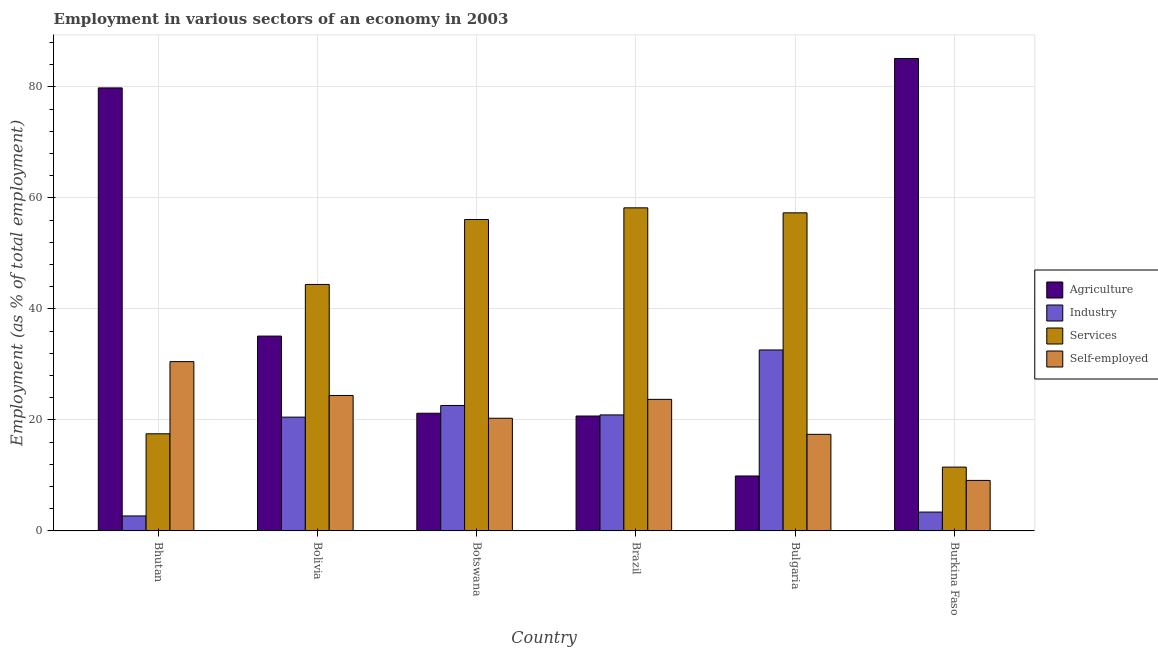How many groups of bars are there?
Give a very brief answer. 6. Are the number of bars on each tick of the X-axis equal?
Offer a terse response. Yes. How many bars are there on the 5th tick from the right?
Ensure brevity in your answer.  4. In how many cases, is the number of bars for a given country not equal to the number of legend labels?
Your answer should be compact. 0. What is the percentage of workers in industry in Bulgaria?
Offer a terse response. 32.6. Across all countries, what is the maximum percentage of workers in agriculture?
Provide a succinct answer. 85.1. Across all countries, what is the minimum percentage of self employed workers?
Provide a succinct answer. 9.1. In which country was the percentage of workers in agriculture maximum?
Keep it short and to the point. Burkina Faso. In which country was the percentage of workers in agriculture minimum?
Ensure brevity in your answer.  Bulgaria. What is the total percentage of workers in industry in the graph?
Your response must be concise. 102.7. What is the difference between the percentage of workers in services in Bolivia and that in Bulgaria?
Your answer should be very brief. -12.9. What is the difference between the percentage of self employed workers in Burkina Faso and the percentage of workers in services in Bulgaria?
Your answer should be very brief. -48.2. What is the average percentage of self employed workers per country?
Provide a succinct answer. 20.9. What is the difference between the percentage of workers in services and percentage of workers in agriculture in Brazil?
Offer a very short reply. 37.5. What is the ratio of the percentage of self employed workers in Bhutan to that in Bolivia?
Offer a terse response. 1.25. What is the difference between the highest and the second highest percentage of workers in services?
Your answer should be compact. 0.9. What is the difference between the highest and the lowest percentage of workers in agriculture?
Offer a very short reply. 75.2. In how many countries, is the percentage of workers in industry greater than the average percentage of workers in industry taken over all countries?
Your response must be concise. 4. Is the sum of the percentage of workers in agriculture in Bolivia and Botswana greater than the maximum percentage of workers in services across all countries?
Offer a terse response. No. Is it the case that in every country, the sum of the percentage of workers in industry and percentage of self employed workers is greater than the sum of percentage of workers in agriculture and percentage of workers in services?
Ensure brevity in your answer.  No. What does the 1st bar from the left in Bulgaria represents?
Make the answer very short. Agriculture. What does the 2nd bar from the right in Botswana represents?
Offer a very short reply. Services. Is it the case that in every country, the sum of the percentage of workers in agriculture and percentage of workers in industry is greater than the percentage of workers in services?
Keep it short and to the point. No. Are the values on the major ticks of Y-axis written in scientific E-notation?
Offer a very short reply. No. Does the graph contain grids?
Your response must be concise. Yes. How are the legend labels stacked?
Your answer should be compact. Vertical. What is the title of the graph?
Your response must be concise. Employment in various sectors of an economy in 2003. Does "Ease of arranging shipments" appear as one of the legend labels in the graph?
Offer a terse response. No. What is the label or title of the Y-axis?
Provide a short and direct response. Employment (as % of total employment). What is the Employment (as % of total employment) in Agriculture in Bhutan?
Provide a short and direct response. 79.8. What is the Employment (as % of total employment) in Industry in Bhutan?
Provide a succinct answer. 2.7. What is the Employment (as % of total employment) of Services in Bhutan?
Ensure brevity in your answer.  17.5. What is the Employment (as % of total employment) of Self-employed in Bhutan?
Ensure brevity in your answer.  30.5. What is the Employment (as % of total employment) in Agriculture in Bolivia?
Your answer should be very brief. 35.1. What is the Employment (as % of total employment) of Industry in Bolivia?
Your answer should be very brief. 20.5. What is the Employment (as % of total employment) of Services in Bolivia?
Your response must be concise. 44.4. What is the Employment (as % of total employment) of Self-employed in Bolivia?
Offer a very short reply. 24.4. What is the Employment (as % of total employment) of Agriculture in Botswana?
Provide a short and direct response. 21.2. What is the Employment (as % of total employment) of Industry in Botswana?
Make the answer very short. 22.6. What is the Employment (as % of total employment) of Services in Botswana?
Keep it short and to the point. 56.1. What is the Employment (as % of total employment) of Self-employed in Botswana?
Make the answer very short. 20.3. What is the Employment (as % of total employment) of Agriculture in Brazil?
Provide a short and direct response. 20.7. What is the Employment (as % of total employment) in Industry in Brazil?
Offer a very short reply. 20.9. What is the Employment (as % of total employment) of Services in Brazil?
Keep it short and to the point. 58.2. What is the Employment (as % of total employment) of Self-employed in Brazil?
Make the answer very short. 23.7. What is the Employment (as % of total employment) of Agriculture in Bulgaria?
Ensure brevity in your answer.  9.9. What is the Employment (as % of total employment) in Industry in Bulgaria?
Your answer should be very brief. 32.6. What is the Employment (as % of total employment) in Services in Bulgaria?
Ensure brevity in your answer.  57.3. What is the Employment (as % of total employment) of Self-employed in Bulgaria?
Offer a terse response. 17.4. What is the Employment (as % of total employment) of Agriculture in Burkina Faso?
Offer a very short reply. 85.1. What is the Employment (as % of total employment) of Industry in Burkina Faso?
Give a very brief answer. 3.4. What is the Employment (as % of total employment) of Self-employed in Burkina Faso?
Ensure brevity in your answer.  9.1. Across all countries, what is the maximum Employment (as % of total employment) of Agriculture?
Your answer should be compact. 85.1. Across all countries, what is the maximum Employment (as % of total employment) of Industry?
Give a very brief answer. 32.6. Across all countries, what is the maximum Employment (as % of total employment) in Services?
Provide a short and direct response. 58.2. Across all countries, what is the maximum Employment (as % of total employment) in Self-employed?
Your answer should be very brief. 30.5. Across all countries, what is the minimum Employment (as % of total employment) in Agriculture?
Your answer should be very brief. 9.9. Across all countries, what is the minimum Employment (as % of total employment) of Industry?
Ensure brevity in your answer.  2.7. Across all countries, what is the minimum Employment (as % of total employment) of Self-employed?
Your answer should be compact. 9.1. What is the total Employment (as % of total employment) of Agriculture in the graph?
Offer a terse response. 251.8. What is the total Employment (as % of total employment) in Industry in the graph?
Your answer should be very brief. 102.7. What is the total Employment (as % of total employment) in Services in the graph?
Provide a succinct answer. 245. What is the total Employment (as % of total employment) in Self-employed in the graph?
Make the answer very short. 125.4. What is the difference between the Employment (as % of total employment) of Agriculture in Bhutan and that in Bolivia?
Your answer should be compact. 44.7. What is the difference between the Employment (as % of total employment) in Industry in Bhutan and that in Bolivia?
Give a very brief answer. -17.8. What is the difference between the Employment (as % of total employment) in Services in Bhutan and that in Bolivia?
Your answer should be very brief. -26.9. What is the difference between the Employment (as % of total employment) in Self-employed in Bhutan and that in Bolivia?
Offer a terse response. 6.1. What is the difference between the Employment (as % of total employment) in Agriculture in Bhutan and that in Botswana?
Offer a terse response. 58.6. What is the difference between the Employment (as % of total employment) in Industry in Bhutan and that in Botswana?
Your answer should be very brief. -19.9. What is the difference between the Employment (as % of total employment) in Services in Bhutan and that in Botswana?
Give a very brief answer. -38.6. What is the difference between the Employment (as % of total employment) in Self-employed in Bhutan and that in Botswana?
Your answer should be compact. 10.2. What is the difference between the Employment (as % of total employment) in Agriculture in Bhutan and that in Brazil?
Ensure brevity in your answer.  59.1. What is the difference between the Employment (as % of total employment) in Industry in Bhutan and that in Brazil?
Ensure brevity in your answer.  -18.2. What is the difference between the Employment (as % of total employment) of Services in Bhutan and that in Brazil?
Keep it short and to the point. -40.7. What is the difference between the Employment (as % of total employment) of Self-employed in Bhutan and that in Brazil?
Your answer should be compact. 6.8. What is the difference between the Employment (as % of total employment) in Agriculture in Bhutan and that in Bulgaria?
Make the answer very short. 69.9. What is the difference between the Employment (as % of total employment) in Industry in Bhutan and that in Bulgaria?
Ensure brevity in your answer.  -29.9. What is the difference between the Employment (as % of total employment) of Services in Bhutan and that in Bulgaria?
Offer a very short reply. -39.8. What is the difference between the Employment (as % of total employment) of Self-employed in Bhutan and that in Burkina Faso?
Ensure brevity in your answer.  21.4. What is the difference between the Employment (as % of total employment) in Agriculture in Bolivia and that in Botswana?
Make the answer very short. 13.9. What is the difference between the Employment (as % of total employment) of Industry in Bolivia and that in Botswana?
Your answer should be compact. -2.1. What is the difference between the Employment (as % of total employment) of Self-employed in Bolivia and that in Botswana?
Ensure brevity in your answer.  4.1. What is the difference between the Employment (as % of total employment) of Agriculture in Bolivia and that in Brazil?
Your answer should be very brief. 14.4. What is the difference between the Employment (as % of total employment) in Self-employed in Bolivia and that in Brazil?
Your answer should be very brief. 0.7. What is the difference between the Employment (as % of total employment) in Agriculture in Bolivia and that in Bulgaria?
Provide a short and direct response. 25.2. What is the difference between the Employment (as % of total employment) of Services in Bolivia and that in Burkina Faso?
Offer a terse response. 32.9. What is the difference between the Employment (as % of total employment) in Agriculture in Botswana and that in Brazil?
Your answer should be very brief. 0.5. What is the difference between the Employment (as % of total employment) of Industry in Botswana and that in Brazil?
Offer a very short reply. 1.7. What is the difference between the Employment (as % of total employment) of Services in Botswana and that in Bulgaria?
Offer a terse response. -1.2. What is the difference between the Employment (as % of total employment) in Agriculture in Botswana and that in Burkina Faso?
Your answer should be compact. -63.9. What is the difference between the Employment (as % of total employment) of Industry in Botswana and that in Burkina Faso?
Keep it short and to the point. 19.2. What is the difference between the Employment (as % of total employment) in Services in Botswana and that in Burkina Faso?
Provide a short and direct response. 44.6. What is the difference between the Employment (as % of total employment) of Services in Brazil and that in Bulgaria?
Provide a short and direct response. 0.9. What is the difference between the Employment (as % of total employment) of Agriculture in Brazil and that in Burkina Faso?
Give a very brief answer. -64.4. What is the difference between the Employment (as % of total employment) in Services in Brazil and that in Burkina Faso?
Offer a very short reply. 46.7. What is the difference between the Employment (as % of total employment) of Agriculture in Bulgaria and that in Burkina Faso?
Offer a very short reply. -75.2. What is the difference between the Employment (as % of total employment) of Industry in Bulgaria and that in Burkina Faso?
Offer a very short reply. 29.2. What is the difference between the Employment (as % of total employment) in Services in Bulgaria and that in Burkina Faso?
Your response must be concise. 45.8. What is the difference between the Employment (as % of total employment) in Agriculture in Bhutan and the Employment (as % of total employment) in Industry in Bolivia?
Provide a short and direct response. 59.3. What is the difference between the Employment (as % of total employment) in Agriculture in Bhutan and the Employment (as % of total employment) in Services in Bolivia?
Make the answer very short. 35.4. What is the difference between the Employment (as % of total employment) in Agriculture in Bhutan and the Employment (as % of total employment) in Self-employed in Bolivia?
Your answer should be compact. 55.4. What is the difference between the Employment (as % of total employment) in Industry in Bhutan and the Employment (as % of total employment) in Services in Bolivia?
Offer a terse response. -41.7. What is the difference between the Employment (as % of total employment) in Industry in Bhutan and the Employment (as % of total employment) in Self-employed in Bolivia?
Give a very brief answer. -21.7. What is the difference between the Employment (as % of total employment) in Agriculture in Bhutan and the Employment (as % of total employment) in Industry in Botswana?
Your answer should be very brief. 57.2. What is the difference between the Employment (as % of total employment) of Agriculture in Bhutan and the Employment (as % of total employment) of Services in Botswana?
Offer a very short reply. 23.7. What is the difference between the Employment (as % of total employment) of Agriculture in Bhutan and the Employment (as % of total employment) of Self-employed in Botswana?
Your answer should be compact. 59.5. What is the difference between the Employment (as % of total employment) in Industry in Bhutan and the Employment (as % of total employment) in Services in Botswana?
Your answer should be compact. -53.4. What is the difference between the Employment (as % of total employment) in Industry in Bhutan and the Employment (as % of total employment) in Self-employed in Botswana?
Provide a short and direct response. -17.6. What is the difference between the Employment (as % of total employment) of Services in Bhutan and the Employment (as % of total employment) of Self-employed in Botswana?
Give a very brief answer. -2.8. What is the difference between the Employment (as % of total employment) in Agriculture in Bhutan and the Employment (as % of total employment) in Industry in Brazil?
Your answer should be very brief. 58.9. What is the difference between the Employment (as % of total employment) in Agriculture in Bhutan and the Employment (as % of total employment) in Services in Brazil?
Keep it short and to the point. 21.6. What is the difference between the Employment (as % of total employment) in Agriculture in Bhutan and the Employment (as % of total employment) in Self-employed in Brazil?
Provide a short and direct response. 56.1. What is the difference between the Employment (as % of total employment) of Industry in Bhutan and the Employment (as % of total employment) of Services in Brazil?
Provide a succinct answer. -55.5. What is the difference between the Employment (as % of total employment) of Services in Bhutan and the Employment (as % of total employment) of Self-employed in Brazil?
Give a very brief answer. -6.2. What is the difference between the Employment (as % of total employment) in Agriculture in Bhutan and the Employment (as % of total employment) in Industry in Bulgaria?
Make the answer very short. 47.2. What is the difference between the Employment (as % of total employment) of Agriculture in Bhutan and the Employment (as % of total employment) of Self-employed in Bulgaria?
Make the answer very short. 62.4. What is the difference between the Employment (as % of total employment) in Industry in Bhutan and the Employment (as % of total employment) in Services in Bulgaria?
Offer a terse response. -54.6. What is the difference between the Employment (as % of total employment) in Industry in Bhutan and the Employment (as % of total employment) in Self-employed in Bulgaria?
Ensure brevity in your answer.  -14.7. What is the difference between the Employment (as % of total employment) of Agriculture in Bhutan and the Employment (as % of total employment) of Industry in Burkina Faso?
Offer a terse response. 76.4. What is the difference between the Employment (as % of total employment) of Agriculture in Bhutan and the Employment (as % of total employment) of Services in Burkina Faso?
Ensure brevity in your answer.  68.3. What is the difference between the Employment (as % of total employment) of Agriculture in Bhutan and the Employment (as % of total employment) of Self-employed in Burkina Faso?
Keep it short and to the point. 70.7. What is the difference between the Employment (as % of total employment) of Industry in Bhutan and the Employment (as % of total employment) of Services in Burkina Faso?
Your answer should be compact. -8.8. What is the difference between the Employment (as % of total employment) of Industry in Bhutan and the Employment (as % of total employment) of Self-employed in Burkina Faso?
Ensure brevity in your answer.  -6.4. What is the difference between the Employment (as % of total employment) in Services in Bhutan and the Employment (as % of total employment) in Self-employed in Burkina Faso?
Your response must be concise. 8.4. What is the difference between the Employment (as % of total employment) of Agriculture in Bolivia and the Employment (as % of total employment) of Services in Botswana?
Give a very brief answer. -21. What is the difference between the Employment (as % of total employment) in Industry in Bolivia and the Employment (as % of total employment) in Services in Botswana?
Your answer should be very brief. -35.6. What is the difference between the Employment (as % of total employment) of Industry in Bolivia and the Employment (as % of total employment) of Self-employed in Botswana?
Your response must be concise. 0.2. What is the difference between the Employment (as % of total employment) in Services in Bolivia and the Employment (as % of total employment) in Self-employed in Botswana?
Make the answer very short. 24.1. What is the difference between the Employment (as % of total employment) in Agriculture in Bolivia and the Employment (as % of total employment) in Industry in Brazil?
Provide a succinct answer. 14.2. What is the difference between the Employment (as % of total employment) in Agriculture in Bolivia and the Employment (as % of total employment) in Services in Brazil?
Give a very brief answer. -23.1. What is the difference between the Employment (as % of total employment) of Industry in Bolivia and the Employment (as % of total employment) of Services in Brazil?
Your response must be concise. -37.7. What is the difference between the Employment (as % of total employment) of Services in Bolivia and the Employment (as % of total employment) of Self-employed in Brazil?
Offer a terse response. 20.7. What is the difference between the Employment (as % of total employment) in Agriculture in Bolivia and the Employment (as % of total employment) in Industry in Bulgaria?
Your response must be concise. 2.5. What is the difference between the Employment (as % of total employment) in Agriculture in Bolivia and the Employment (as % of total employment) in Services in Bulgaria?
Give a very brief answer. -22.2. What is the difference between the Employment (as % of total employment) of Industry in Bolivia and the Employment (as % of total employment) of Services in Bulgaria?
Keep it short and to the point. -36.8. What is the difference between the Employment (as % of total employment) in Services in Bolivia and the Employment (as % of total employment) in Self-employed in Bulgaria?
Provide a short and direct response. 27. What is the difference between the Employment (as % of total employment) in Agriculture in Bolivia and the Employment (as % of total employment) in Industry in Burkina Faso?
Provide a succinct answer. 31.7. What is the difference between the Employment (as % of total employment) of Agriculture in Bolivia and the Employment (as % of total employment) of Services in Burkina Faso?
Offer a very short reply. 23.6. What is the difference between the Employment (as % of total employment) in Services in Bolivia and the Employment (as % of total employment) in Self-employed in Burkina Faso?
Make the answer very short. 35.3. What is the difference between the Employment (as % of total employment) in Agriculture in Botswana and the Employment (as % of total employment) in Services in Brazil?
Make the answer very short. -37. What is the difference between the Employment (as % of total employment) in Agriculture in Botswana and the Employment (as % of total employment) in Self-employed in Brazil?
Give a very brief answer. -2.5. What is the difference between the Employment (as % of total employment) of Industry in Botswana and the Employment (as % of total employment) of Services in Brazil?
Your answer should be very brief. -35.6. What is the difference between the Employment (as % of total employment) of Industry in Botswana and the Employment (as % of total employment) of Self-employed in Brazil?
Your answer should be very brief. -1.1. What is the difference between the Employment (as % of total employment) in Services in Botswana and the Employment (as % of total employment) in Self-employed in Brazil?
Provide a short and direct response. 32.4. What is the difference between the Employment (as % of total employment) in Agriculture in Botswana and the Employment (as % of total employment) in Services in Bulgaria?
Ensure brevity in your answer.  -36.1. What is the difference between the Employment (as % of total employment) of Industry in Botswana and the Employment (as % of total employment) of Services in Bulgaria?
Ensure brevity in your answer.  -34.7. What is the difference between the Employment (as % of total employment) in Industry in Botswana and the Employment (as % of total employment) in Self-employed in Bulgaria?
Your response must be concise. 5.2. What is the difference between the Employment (as % of total employment) of Services in Botswana and the Employment (as % of total employment) of Self-employed in Bulgaria?
Make the answer very short. 38.7. What is the difference between the Employment (as % of total employment) of Agriculture in Botswana and the Employment (as % of total employment) of Industry in Burkina Faso?
Make the answer very short. 17.8. What is the difference between the Employment (as % of total employment) in Industry in Botswana and the Employment (as % of total employment) in Services in Burkina Faso?
Your answer should be compact. 11.1. What is the difference between the Employment (as % of total employment) in Services in Botswana and the Employment (as % of total employment) in Self-employed in Burkina Faso?
Keep it short and to the point. 47. What is the difference between the Employment (as % of total employment) of Agriculture in Brazil and the Employment (as % of total employment) of Industry in Bulgaria?
Give a very brief answer. -11.9. What is the difference between the Employment (as % of total employment) of Agriculture in Brazil and the Employment (as % of total employment) of Services in Bulgaria?
Provide a short and direct response. -36.6. What is the difference between the Employment (as % of total employment) of Industry in Brazil and the Employment (as % of total employment) of Services in Bulgaria?
Your answer should be very brief. -36.4. What is the difference between the Employment (as % of total employment) in Services in Brazil and the Employment (as % of total employment) in Self-employed in Bulgaria?
Your response must be concise. 40.8. What is the difference between the Employment (as % of total employment) of Industry in Brazil and the Employment (as % of total employment) of Self-employed in Burkina Faso?
Provide a short and direct response. 11.8. What is the difference between the Employment (as % of total employment) of Services in Brazil and the Employment (as % of total employment) of Self-employed in Burkina Faso?
Provide a short and direct response. 49.1. What is the difference between the Employment (as % of total employment) of Agriculture in Bulgaria and the Employment (as % of total employment) of Self-employed in Burkina Faso?
Your answer should be very brief. 0.8. What is the difference between the Employment (as % of total employment) in Industry in Bulgaria and the Employment (as % of total employment) in Services in Burkina Faso?
Make the answer very short. 21.1. What is the difference between the Employment (as % of total employment) of Services in Bulgaria and the Employment (as % of total employment) of Self-employed in Burkina Faso?
Provide a succinct answer. 48.2. What is the average Employment (as % of total employment) of Agriculture per country?
Give a very brief answer. 41.97. What is the average Employment (as % of total employment) in Industry per country?
Ensure brevity in your answer.  17.12. What is the average Employment (as % of total employment) in Services per country?
Ensure brevity in your answer.  40.83. What is the average Employment (as % of total employment) of Self-employed per country?
Your response must be concise. 20.9. What is the difference between the Employment (as % of total employment) of Agriculture and Employment (as % of total employment) of Industry in Bhutan?
Give a very brief answer. 77.1. What is the difference between the Employment (as % of total employment) of Agriculture and Employment (as % of total employment) of Services in Bhutan?
Provide a succinct answer. 62.3. What is the difference between the Employment (as % of total employment) of Agriculture and Employment (as % of total employment) of Self-employed in Bhutan?
Offer a terse response. 49.3. What is the difference between the Employment (as % of total employment) of Industry and Employment (as % of total employment) of Services in Bhutan?
Provide a succinct answer. -14.8. What is the difference between the Employment (as % of total employment) of Industry and Employment (as % of total employment) of Self-employed in Bhutan?
Keep it short and to the point. -27.8. What is the difference between the Employment (as % of total employment) of Services and Employment (as % of total employment) of Self-employed in Bhutan?
Ensure brevity in your answer.  -13. What is the difference between the Employment (as % of total employment) in Agriculture and Employment (as % of total employment) in Industry in Bolivia?
Provide a short and direct response. 14.6. What is the difference between the Employment (as % of total employment) of Agriculture and Employment (as % of total employment) of Services in Bolivia?
Offer a very short reply. -9.3. What is the difference between the Employment (as % of total employment) of Agriculture and Employment (as % of total employment) of Self-employed in Bolivia?
Give a very brief answer. 10.7. What is the difference between the Employment (as % of total employment) of Industry and Employment (as % of total employment) of Services in Bolivia?
Your response must be concise. -23.9. What is the difference between the Employment (as % of total employment) in Industry and Employment (as % of total employment) in Self-employed in Bolivia?
Your answer should be compact. -3.9. What is the difference between the Employment (as % of total employment) in Agriculture and Employment (as % of total employment) in Industry in Botswana?
Make the answer very short. -1.4. What is the difference between the Employment (as % of total employment) in Agriculture and Employment (as % of total employment) in Services in Botswana?
Offer a very short reply. -34.9. What is the difference between the Employment (as % of total employment) in Industry and Employment (as % of total employment) in Services in Botswana?
Ensure brevity in your answer.  -33.5. What is the difference between the Employment (as % of total employment) of Industry and Employment (as % of total employment) of Self-employed in Botswana?
Your response must be concise. 2.3. What is the difference between the Employment (as % of total employment) of Services and Employment (as % of total employment) of Self-employed in Botswana?
Ensure brevity in your answer.  35.8. What is the difference between the Employment (as % of total employment) of Agriculture and Employment (as % of total employment) of Services in Brazil?
Keep it short and to the point. -37.5. What is the difference between the Employment (as % of total employment) of Agriculture and Employment (as % of total employment) of Self-employed in Brazil?
Provide a short and direct response. -3. What is the difference between the Employment (as % of total employment) in Industry and Employment (as % of total employment) in Services in Brazil?
Your response must be concise. -37.3. What is the difference between the Employment (as % of total employment) in Industry and Employment (as % of total employment) in Self-employed in Brazil?
Your response must be concise. -2.8. What is the difference between the Employment (as % of total employment) of Services and Employment (as % of total employment) of Self-employed in Brazil?
Your answer should be compact. 34.5. What is the difference between the Employment (as % of total employment) of Agriculture and Employment (as % of total employment) of Industry in Bulgaria?
Offer a very short reply. -22.7. What is the difference between the Employment (as % of total employment) in Agriculture and Employment (as % of total employment) in Services in Bulgaria?
Provide a short and direct response. -47.4. What is the difference between the Employment (as % of total employment) in Agriculture and Employment (as % of total employment) in Self-employed in Bulgaria?
Ensure brevity in your answer.  -7.5. What is the difference between the Employment (as % of total employment) of Industry and Employment (as % of total employment) of Services in Bulgaria?
Offer a very short reply. -24.7. What is the difference between the Employment (as % of total employment) of Industry and Employment (as % of total employment) of Self-employed in Bulgaria?
Provide a succinct answer. 15.2. What is the difference between the Employment (as % of total employment) in Services and Employment (as % of total employment) in Self-employed in Bulgaria?
Offer a very short reply. 39.9. What is the difference between the Employment (as % of total employment) in Agriculture and Employment (as % of total employment) in Industry in Burkina Faso?
Make the answer very short. 81.7. What is the difference between the Employment (as % of total employment) in Agriculture and Employment (as % of total employment) in Services in Burkina Faso?
Provide a short and direct response. 73.6. What is the difference between the Employment (as % of total employment) of Agriculture and Employment (as % of total employment) of Self-employed in Burkina Faso?
Offer a terse response. 76. What is the difference between the Employment (as % of total employment) in Services and Employment (as % of total employment) in Self-employed in Burkina Faso?
Your answer should be compact. 2.4. What is the ratio of the Employment (as % of total employment) of Agriculture in Bhutan to that in Bolivia?
Give a very brief answer. 2.27. What is the ratio of the Employment (as % of total employment) of Industry in Bhutan to that in Bolivia?
Offer a terse response. 0.13. What is the ratio of the Employment (as % of total employment) of Services in Bhutan to that in Bolivia?
Offer a terse response. 0.39. What is the ratio of the Employment (as % of total employment) of Self-employed in Bhutan to that in Bolivia?
Provide a succinct answer. 1.25. What is the ratio of the Employment (as % of total employment) of Agriculture in Bhutan to that in Botswana?
Your answer should be very brief. 3.76. What is the ratio of the Employment (as % of total employment) in Industry in Bhutan to that in Botswana?
Ensure brevity in your answer.  0.12. What is the ratio of the Employment (as % of total employment) in Services in Bhutan to that in Botswana?
Keep it short and to the point. 0.31. What is the ratio of the Employment (as % of total employment) of Self-employed in Bhutan to that in Botswana?
Your response must be concise. 1.5. What is the ratio of the Employment (as % of total employment) in Agriculture in Bhutan to that in Brazil?
Your answer should be compact. 3.86. What is the ratio of the Employment (as % of total employment) of Industry in Bhutan to that in Brazil?
Make the answer very short. 0.13. What is the ratio of the Employment (as % of total employment) of Services in Bhutan to that in Brazil?
Offer a terse response. 0.3. What is the ratio of the Employment (as % of total employment) in Self-employed in Bhutan to that in Brazil?
Provide a succinct answer. 1.29. What is the ratio of the Employment (as % of total employment) in Agriculture in Bhutan to that in Bulgaria?
Offer a terse response. 8.06. What is the ratio of the Employment (as % of total employment) of Industry in Bhutan to that in Bulgaria?
Your answer should be compact. 0.08. What is the ratio of the Employment (as % of total employment) of Services in Bhutan to that in Bulgaria?
Keep it short and to the point. 0.31. What is the ratio of the Employment (as % of total employment) of Self-employed in Bhutan to that in Bulgaria?
Keep it short and to the point. 1.75. What is the ratio of the Employment (as % of total employment) in Agriculture in Bhutan to that in Burkina Faso?
Give a very brief answer. 0.94. What is the ratio of the Employment (as % of total employment) of Industry in Bhutan to that in Burkina Faso?
Your answer should be very brief. 0.79. What is the ratio of the Employment (as % of total employment) of Services in Bhutan to that in Burkina Faso?
Provide a succinct answer. 1.52. What is the ratio of the Employment (as % of total employment) in Self-employed in Bhutan to that in Burkina Faso?
Your response must be concise. 3.35. What is the ratio of the Employment (as % of total employment) of Agriculture in Bolivia to that in Botswana?
Provide a short and direct response. 1.66. What is the ratio of the Employment (as % of total employment) of Industry in Bolivia to that in Botswana?
Provide a short and direct response. 0.91. What is the ratio of the Employment (as % of total employment) in Services in Bolivia to that in Botswana?
Provide a succinct answer. 0.79. What is the ratio of the Employment (as % of total employment) in Self-employed in Bolivia to that in Botswana?
Keep it short and to the point. 1.2. What is the ratio of the Employment (as % of total employment) in Agriculture in Bolivia to that in Brazil?
Your answer should be compact. 1.7. What is the ratio of the Employment (as % of total employment) of Industry in Bolivia to that in Brazil?
Keep it short and to the point. 0.98. What is the ratio of the Employment (as % of total employment) of Services in Bolivia to that in Brazil?
Offer a terse response. 0.76. What is the ratio of the Employment (as % of total employment) of Self-employed in Bolivia to that in Brazil?
Make the answer very short. 1.03. What is the ratio of the Employment (as % of total employment) in Agriculture in Bolivia to that in Bulgaria?
Give a very brief answer. 3.55. What is the ratio of the Employment (as % of total employment) of Industry in Bolivia to that in Bulgaria?
Provide a succinct answer. 0.63. What is the ratio of the Employment (as % of total employment) of Services in Bolivia to that in Bulgaria?
Keep it short and to the point. 0.77. What is the ratio of the Employment (as % of total employment) in Self-employed in Bolivia to that in Bulgaria?
Your answer should be compact. 1.4. What is the ratio of the Employment (as % of total employment) of Agriculture in Bolivia to that in Burkina Faso?
Your response must be concise. 0.41. What is the ratio of the Employment (as % of total employment) in Industry in Bolivia to that in Burkina Faso?
Give a very brief answer. 6.03. What is the ratio of the Employment (as % of total employment) in Services in Bolivia to that in Burkina Faso?
Provide a short and direct response. 3.86. What is the ratio of the Employment (as % of total employment) in Self-employed in Bolivia to that in Burkina Faso?
Ensure brevity in your answer.  2.68. What is the ratio of the Employment (as % of total employment) in Agriculture in Botswana to that in Brazil?
Make the answer very short. 1.02. What is the ratio of the Employment (as % of total employment) of Industry in Botswana to that in Brazil?
Give a very brief answer. 1.08. What is the ratio of the Employment (as % of total employment) of Services in Botswana to that in Brazil?
Ensure brevity in your answer.  0.96. What is the ratio of the Employment (as % of total employment) of Self-employed in Botswana to that in Brazil?
Provide a short and direct response. 0.86. What is the ratio of the Employment (as % of total employment) in Agriculture in Botswana to that in Bulgaria?
Your answer should be very brief. 2.14. What is the ratio of the Employment (as % of total employment) in Industry in Botswana to that in Bulgaria?
Give a very brief answer. 0.69. What is the ratio of the Employment (as % of total employment) in Services in Botswana to that in Bulgaria?
Keep it short and to the point. 0.98. What is the ratio of the Employment (as % of total employment) in Self-employed in Botswana to that in Bulgaria?
Give a very brief answer. 1.17. What is the ratio of the Employment (as % of total employment) in Agriculture in Botswana to that in Burkina Faso?
Give a very brief answer. 0.25. What is the ratio of the Employment (as % of total employment) of Industry in Botswana to that in Burkina Faso?
Provide a succinct answer. 6.65. What is the ratio of the Employment (as % of total employment) in Services in Botswana to that in Burkina Faso?
Make the answer very short. 4.88. What is the ratio of the Employment (as % of total employment) of Self-employed in Botswana to that in Burkina Faso?
Make the answer very short. 2.23. What is the ratio of the Employment (as % of total employment) of Agriculture in Brazil to that in Bulgaria?
Your answer should be very brief. 2.09. What is the ratio of the Employment (as % of total employment) in Industry in Brazil to that in Bulgaria?
Give a very brief answer. 0.64. What is the ratio of the Employment (as % of total employment) in Services in Brazil to that in Bulgaria?
Give a very brief answer. 1.02. What is the ratio of the Employment (as % of total employment) in Self-employed in Brazil to that in Bulgaria?
Your answer should be compact. 1.36. What is the ratio of the Employment (as % of total employment) of Agriculture in Brazil to that in Burkina Faso?
Your answer should be very brief. 0.24. What is the ratio of the Employment (as % of total employment) of Industry in Brazil to that in Burkina Faso?
Provide a short and direct response. 6.15. What is the ratio of the Employment (as % of total employment) in Services in Brazil to that in Burkina Faso?
Your answer should be compact. 5.06. What is the ratio of the Employment (as % of total employment) of Self-employed in Brazil to that in Burkina Faso?
Give a very brief answer. 2.6. What is the ratio of the Employment (as % of total employment) of Agriculture in Bulgaria to that in Burkina Faso?
Keep it short and to the point. 0.12. What is the ratio of the Employment (as % of total employment) in Industry in Bulgaria to that in Burkina Faso?
Your response must be concise. 9.59. What is the ratio of the Employment (as % of total employment) in Services in Bulgaria to that in Burkina Faso?
Make the answer very short. 4.98. What is the ratio of the Employment (as % of total employment) in Self-employed in Bulgaria to that in Burkina Faso?
Your response must be concise. 1.91. What is the difference between the highest and the second highest Employment (as % of total employment) in Self-employed?
Make the answer very short. 6.1. What is the difference between the highest and the lowest Employment (as % of total employment) of Agriculture?
Your answer should be very brief. 75.2. What is the difference between the highest and the lowest Employment (as % of total employment) in Industry?
Your answer should be very brief. 29.9. What is the difference between the highest and the lowest Employment (as % of total employment) of Services?
Keep it short and to the point. 46.7. What is the difference between the highest and the lowest Employment (as % of total employment) in Self-employed?
Offer a very short reply. 21.4. 